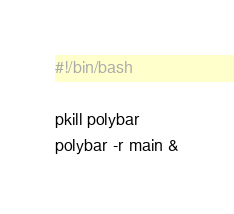Convert code to text. <code><loc_0><loc_0><loc_500><loc_500><_Bash_>#!/bin/bash

pkill polybar
polybar -r main &
</code> 